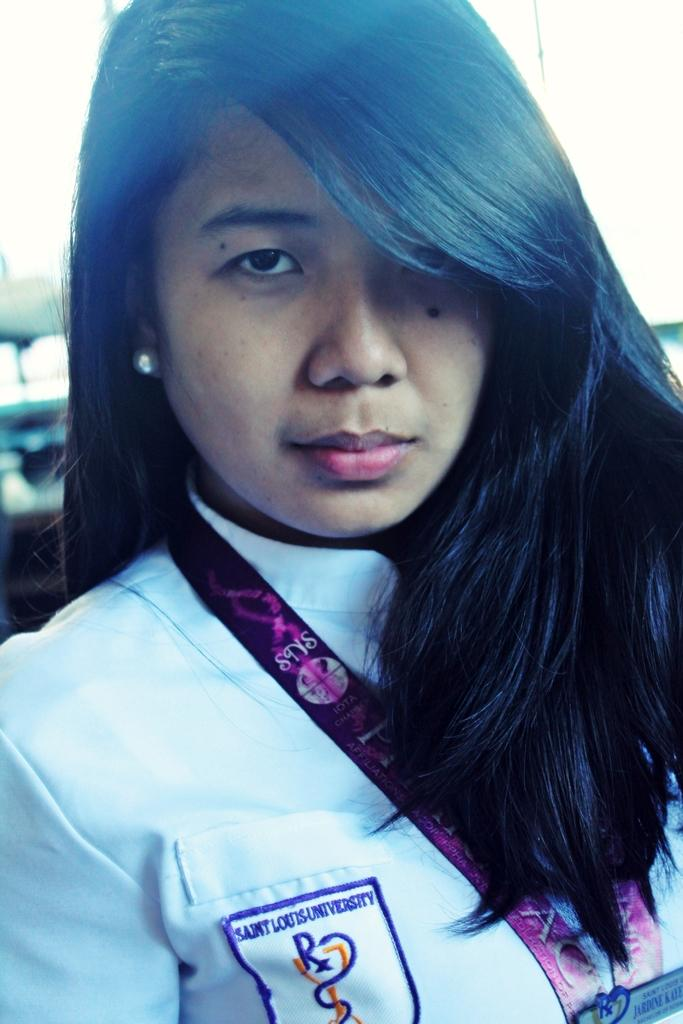Who is the main subject in the image? There is a lady in the image. What is the lady wearing? The lady is wearing a white dress. What items does the lady have with her? The lady has an access card and a sticker with writing on it. Can you describe the background of the image? The background of the image is blurred. What is the rate of increase in the number of wars in the image? There is no mention of wars or any increase in the number of wars in the image. The image features a lady with an access card and a sticker, and the background is blurred. 